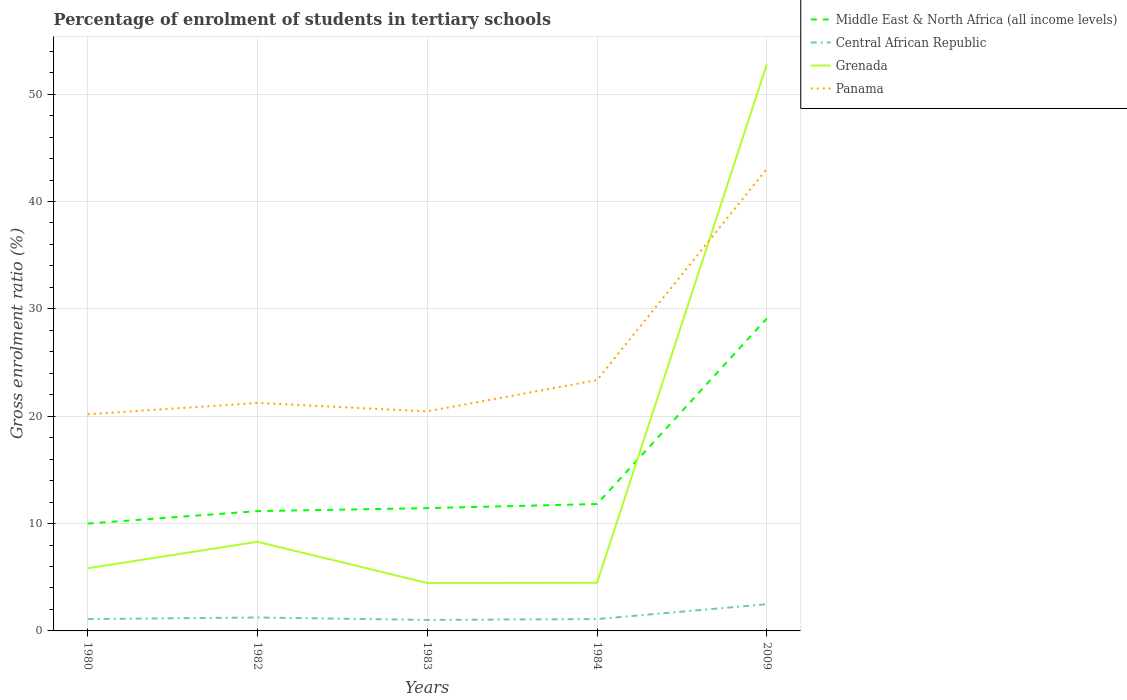Is the number of lines equal to the number of legend labels?
Provide a short and direct response. Yes. Across all years, what is the maximum percentage of students enrolled in tertiary schools in Middle East & North Africa (all income levels)?
Provide a succinct answer. 10. What is the total percentage of students enrolled in tertiary schools in Middle East & North Africa (all income levels) in the graph?
Provide a short and direct response. -0.38. What is the difference between the highest and the second highest percentage of students enrolled in tertiary schools in Grenada?
Make the answer very short. 48.31. Is the percentage of students enrolled in tertiary schools in Panama strictly greater than the percentage of students enrolled in tertiary schools in Central African Republic over the years?
Offer a terse response. No. How many lines are there?
Offer a very short reply. 4. How many years are there in the graph?
Provide a short and direct response. 5. Are the values on the major ticks of Y-axis written in scientific E-notation?
Ensure brevity in your answer.  No. Does the graph contain grids?
Your answer should be compact. Yes. Where does the legend appear in the graph?
Make the answer very short. Top right. How are the legend labels stacked?
Your answer should be compact. Vertical. What is the title of the graph?
Keep it short and to the point. Percentage of enrolment of students in tertiary schools. Does "Guinea" appear as one of the legend labels in the graph?
Ensure brevity in your answer.  No. What is the label or title of the X-axis?
Offer a very short reply. Years. What is the label or title of the Y-axis?
Provide a succinct answer. Gross enrolment ratio (%). What is the Gross enrolment ratio (%) in Middle East & North Africa (all income levels) in 1980?
Give a very brief answer. 10. What is the Gross enrolment ratio (%) in Central African Republic in 1980?
Provide a short and direct response. 1.1. What is the Gross enrolment ratio (%) in Grenada in 1980?
Make the answer very short. 5.83. What is the Gross enrolment ratio (%) of Panama in 1980?
Your answer should be very brief. 20.18. What is the Gross enrolment ratio (%) of Middle East & North Africa (all income levels) in 1982?
Provide a succinct answer. 11.16. What is the Gross enrolment ratio (%) in Central African Republic in 1982?
Give a very brief answer. 1.25. What is the Gross enrolment ratio (%) of Grenada in 1982?
Ensure brevity in your answer.  8.3. What is the Gross enrolment ratio (%) of Panama in 1982?
Provide a succinct answer. 21.24. What is the Gross enrolment ratio (%) in Middle East & North Africa (all income levels) in 1983?
Make the answer very short. 11.44. What is the Gross enrolment ratio (%) in Central African Republic in 1983?
Provide a succinct answer. 1.02. What is the Gross enrolment ratio (%) in Grenada in 1983?
Provide a succinct answer. 4.47. What is the Gross enrolment ratio (%) in Panama in 1983?
Provide a short and direct response. 20.45. What is the Gross enrolment ratio (%) of Middle East & North Africa (all income levels) in 1984?
Give a very brief answer. 11.82. What is the Gross enrolment ratio (%) of Central African Republic in 1984?
Keep it short and to the point. 1.1. What is the Gross enrolment ratio (%) of Grenada in 1984?
Provide a short and direct response. 4.48. What is the Gross enrolment ratio (%) of Panama in 1984?
Your answer should be compact. 23.36. What is the Gross enrolment ratio (%) in Middle East & North Africa (all income levels) in 2009?
Give a very brief answer. 29.1. What is the Gross enrolment ratio (%) in Central African Republic in 2009?
Your answer should be very brief. 2.49. What is the Gross enrolment ratio (%) of Grenada in 2009?
Give a very brief answer. 52.77. What is the Gross enrolment ratio (%) in Panama in 2009?
Make the answer very short. 43.03. Across all years, what is the maximum Gross enrolment ratio (%) of Middle East & North Africa (all income levels)?
Provide a succinct answer. 29.1. Across all years, what is the maximum Gross enrolment ratio (%) in Central African Republic?
Provide a short and direct response. 2.49. Across all years, what is the maximum Gross enrolment ratio (%) of Grenada?
Your response must be concise. 52.77. Across all years, what is the maximum Gross enrolment ratio (%) of Panama?
Your response must be concise. 43.03. Across all years, what is the minimum Gross enrolment ratio (%) of Middle East & North Africa (all income levels)?
Provide a succinct answer. 10. Across all years, what is the minimum Gross enrolment ratio (%) of Central African Republic?
Offer a terse response. 1.02. Across all years, what is the minimum Gross enrolment ratio (%) of Grenada?
Ensure brevity in your answer.  4.47. Across all years, what is the minimum Gross enrolment ratio (%) in Panama?
Give a very brief answer. 20.18. What is the total Gross enrolment ratio (%) in Middle East & North Africa (all income levels) in the graph?
Your response must be concise. 73.52. What is the total Gross enrolment ratio (%) in Central African Republic in the graph?
Ensure brevity in your answer.  6.97. What is the total Gross enrolment ratio (%) of Grenada in the graph?
Provide a short and direct response. 75.86. What is the total Gross enrolment ratio (%) of Panama in the graph?
Ensure brevity in your answer.  128.26. What is the difference between the Gross enrolment ratio (%) of Middle East & North Africa (all income levels) in 1980 and that in 1982?
Provide a short and direct response. -1.16. What is the difference between the Gross enrolment ratio (%) in Central African Republic in 1980 and that in 1982?
Offer a very short reply. -0.15. What is the difference between the Gross enrolment ratio (%) of Grenada in 1980 and that in 1982?
Make the answer very short. -2.47. What is the difference between the Gross enrolment ratio (%) of Panama in 1980 and that in 1982?
Your answer should be very brief. -1.05. What is the difference between the Gross enrolment ratio (%) in Middle East & North Africa (all income levels) in 1980 and that in 1983?
Offer a terse response. -1.44. What is the difference between the Gross enrolment ratio (%) of Central African Republic in 1980 and that in 1983?
Keep it short and to the point. 0.08. What is the difference between the Gross enrolment ratio (%) in Grenada in 1980 and that in 1983?
Offer a terse response. 1.37. What is the difference between the Gross enrolment ratio (%) of Panama in 1980 and that in 1983?
Give a very brief answer. -0.27. What is the difference between the Gross enrolment ratio (%) of Middle East & North Africa (all income levels) in 1980 and that in 1984?
Offer a terse response. -1.82. What is the difference between the Gross enrolment ratio (%) in Central African Republic in 1980 and that in 1984?
Your answer should be very brief. -0. What is the difference between the Gross enrolment ratio (%) of Grenada in 1980 and that in 1984?
Make the answer very short. 1.35. What is the difference between the Gross enrolment ratio (%) of Panama in 1980 and that in 1984?
Your answer should be very brief. -3.18. What is the difference between the Gross enrolment ratio (%) in Middle East & North Africa (all income levels) in 1980 and that in 2009?
Ensure brevity in your answer.  -19.1. What is the difference between the Gross enrolment ratio (%) of Central African Republic in 1980 and that in 2009?
Keep it short and to the point. -1.39. What is the difference between the Gross enrolment ratio (%) in Grenada in 1980 and that in 2009?
Offer a terse response. -46.94. What is the difference between the Gross enrolment ratio (%) in Panama in 1980 and that in 2009?
Provide a succinct answer. -22.85. What is the difference between the Gross enrolment ratio (%) in Middle East & North Africa (all income levels) in 1982 and that in 1983?
Provide a succinct answer. -0.28. What is the difference between the Gross enrolment ratio (%) in Central African Republic in 1982 and that in 1983?
Keep it short and to the point. 0.23. What is the difference between the Gross enrolment ratio (%) of Grenada in 1982 and that in 1983?
Ensure brevity in your answer.  3.84. What is the difference between the Gross enrolment ratio (%) of Panama in 1982 and that in 1983?
Your answer should be compact. 0.79. What is the difference between the Gross enrolment ratio (%) in Middle East & North Africa (all income levels) in 1982 and that in 1984?
Offer a very short reply. -0.66. What is the difference between the Gross enrolment ratio (%) in Central African Republic in 1982 and that in 1984?
Keep it short and to the point. 0.15. What is the difference between the Gross enrolment ratio (%) of Grenada in 1982 and that in 1984?
Offer a terse response. 3.82. What is the difference between the Gross enrolment ratio (%) in Panama in 1982 and that in 1984?
Your answer should be very brief. -2.12. What is the difference between the Gross enrolment ratio (%) in Middle East & North Africa (all income levels) in 1982 and that in 2009?
Offer a very short reply. -17.94. What is the difference between the Gross enrolment ratio (%) in Central African Republic in 1982 and that in 2009?
Keep it short and to the point. -1.24. What is the difference between the Gross enrolment ratio (%) of Grenada in 1982 and that in 2009?
Your answer should be compact. -44.47. What is the difference between the Gross enrolment ratio (%) of Panama in 1982 and that in 2009?
Provide a short and direct response. -21.79. What is the difference between the Gross enrolment ratio (%) of Middle East & North Africa (all income levels) in 1983 and that in 1984?
Offer a very short reply. -0.38. What is the difference between the Gross enrolment ratio (%) in Central African Republic in 1983 and that in 1984?
Your response must be concise. -0.08. What is the difference between the Gross enrolment ratio (%) in Grenada in 1983 and that in 1984?
Your answer should be compact. -0.02. What is the difference between the Gross enrolment ratio (%) of Panama in 1983 and that in 1984?
Make the answer very short. -2.91. What is the difference between the Gross enrolment ratio (%) of Middle East & North Africa (all income levels) in 1983 and that in 2009?
Offer a terse response. -17.67. What is the difference between the Gross enrolment ratio (%) of Central African Republic in 1983 and that in 2009?
Provide a short and direct response. -1.47. What is the difference between the Gross enrolment ratio (%) of Grenada in 1983 and that in 2009?
Give a very brief answer. -48.31. What is the difference between the Gross enrolment ratio (%) of Panama in 1983 and that in 2009?
Offer a terse response. -22.58. What is the difference between the Gross enrolment ratio (%) in Middle East & North Africa (all income levels) in 1984 and that in 2009?
Provide a short and direct response. -17.29. What is the difference between the Gross enrolment ratio (%) in Central African Republic in 1984 and that in 2009?
Provide a short and direct response. -1.39. What is the difference between the Gross enrolment ratio (%) of Grenada in 1984 and that in 2009?
Offer a terse response. -48.29. What is the difference between the Gross enrolment ratio (%) in Panama in 1984 and that in 2009?
Offer a very short reply. -19.67. What is the difference between the Gross enrolment ratio (%) in Middle East & North Africa (all income levels) in 1980 and the Gross enrolment ratio (%) in Central African Republic in 1982?
Keep it short and to the point. 8.75. What is the difference between the Gross enrolment ratio (%) in Middle East & North Africa (all income levels) in 1980 and the Gross enrolment ratio (%) in Grenada in 1982?
Provide a succinct answer. 1.7. What is the difference between the Gross enrolment ratio (%) of Middle East & North Africa (all income levels) in 1980 and the Gross enrolment ratio (%) of Panama in 1982?
Your answer should be compact. -11.24. What is the difference between the Gross enrolment ratio (%) in Central African Republic in 1980 and the Gross enrolment ratio (%) in Grenada in 1982?
Offer a terse response. -7.2. What is the difference between the Gross enrolment ratio (%) in Central African Republic in 1980 and the Gross enrolment ratio (%) in Panama in 1982?
Ensure brevity in your answer.  -20.14. What is the difference between the Gross enrolment ratio (%) of Grenada in 1980 and the Gross enrolment ratio (%) of Panama in 1982?
Keep it short and to the point. -15.4. What is the difference between the Gross enrolment ratio (%) of Middle East & North Africa (all income levels) in 1980 and the Gross enrolment ratio (%) of Central African Republic in 1983?
Offer a terse response. 8.98. What is the difference between the Gross enrolment ratio (%) in Middle East & North Africa (all income levels) in 1980 and the Gross enrolment ratio (%) in Grenada in 1983?
Your answer should be very brief. 5.53. What is the difference between the Gross enrolment ratio (%) of Middle East & North Africa (all income levels) in 1980 and the Gross enrolment ratio (%) of Panama in 1983?
Offer a very short reply. -10.45. What is the difference between the Gross enrolment ratio (%) in Central African Republic in 1980 and the Gross enrolment ratio (%) in Grenada in 1983?
Offer a very short reply. -3.36. What is the difference between the Gross enrolment ratio (%) of Central African Republic in 1980 and the Gross enrolment ratio (%) of Panama in 1983?
Provide a short and direct response. -19.35. What is the difference between the Gross enrolment ratio (%) of Grenada in 1980 and the Gross enrolment ratio (%) of Panama in 1983?
Offer a very short reply. -14.61. What is the difference between the Gross enrolment ratio (%) of Middle East & North Africa (all income levels) in 1980 and the Gross enrolment ratio (%) of Central African Republic in 1984?
Offer a very short reply. 8.9. What is the difference between the Gross enrolment ratio (%) in Middle East & North Africa (all income levels) in 1980 and the Gross enrolment ratio (%) in Grenada in 1984?
Offer a very short reply. 5.52. What is the difference between the Gross enrolment ratio (%) of Middle East & North Africa (all income levels) in 1980 and the Gross enrolment ratio (%) of Panama in 1984?
Your answer should be compact. -13.36. What is the difference between the Gross enrolment ratio (%) of Central African Republic in 1980 and the Gross enrolment ratio (%) of Grenada in 1984?
Provide a short and direct response. -3.38. What is the difference between the Gross enrolment ratio (%) in Central African Republic in 1980 and the Gross enrolment ratio (%) in Panama in 1984?
Provide a succinct answer. -22.26. What is the difference between the Gross enrolment ratio (%) in Grenada in 1980 and the Gross enrolment ratio (%) in Panama in 1984?
Keep it short and to the point. -17.53. What is the difference between the Gross enrolment ratio (%) in Middle East & North Africa (all income levels) in 1980 and the Gross enrolment ratio (%) in Central African Republic in 2009?
Make the answer very short. 7.51. What is the difference between the Gross enrolment ratio (%) in Middle East & North Africa (all income levels) in 1980 and the Gross enrolment ratio (%) in Grenada in 2009?
Offer a terse response. -42.77. What is the difference between the Gross enrolment ratio (%) of Middle East & North Africa (all income levels) in 1980 and the Gross enrolment ratio (%) of Panama in 2009?
Your answer should be compact. -33.03. What is the difference between the Gross enrolment ratio (%) of Central African Republic in 1980 and the Gross enrolment ratio (%) of Grenada in 2009?
Give a very brief answer. -51.67. What is the difference between the Gross enrolment ratio (%) in Central African Republic in 1980 and the Gross enrolment ratio (%) in Panama in 2009?
Your answer should be compact. -41.93. What is the difference between the Gross enrolment ratio (%) of Grenada in 1980 and the Gross enrolment ratio (%) of Panama in 2009?
Keep it short and to the point. -37.2. What is the difference between the Gross enrolment ratio (%) of Middle East & North Africa (all income levels) in 1982 and the Gross enrolment ratio (%) of Central African Republic in 1983?
Provide a short and direct response. 10.13. What is the difference between the Gross enrolment ratio (%) of Middle East & North Africa (all income levels) in 1982 and the Gross enrolment ratio (%) of Grenada in 1983?
Your answer should be very brief. 6.69. What is the difference between the Gross enrolment ratio (%) in Middle East & North Africa (all income levels) in 1982 and the Gross enrolment ratio (%) in Panama in 1983?
Offer a terse response. -9.29. What is the difference between the Gross enrolment ratio (%) of Central African Republic in 1982 and the Gross enrolment ratio (%) of Grenada in 1983?
Provide a succinct answer. -3.21. What is the difference between the Gross enrolment ratio (%) of Central African Republic in 1982 and the Gross enrolment ratio (%) of Panama in 1983?
Provide a short and direct response. -19.2. What is the difference between the Gross enrolment ratio (%) in Grenada in 1982 and the Gross enrolment ratio (%) in Panama in 1983?
Your response must be concise. -12.15. What is the difference between the Gross enrolment ratio (%) of Middle East & North Africa (all income levels) in 1982 and the Gross enrolment ratio (%) of Central African Republic in 1984?
Make the answer very short. 10.05. What is the difference between the Gross enrolment ratio (%) in Middle East & North Africa (all income levels) in 1982 and the Gross enrolment ratio (%) in Grenada in 1984?
Your answer should be very brief. 6.68. What is the difference between the Gross enrolment ratio (%) in Middle East & North Africa (all income levels) in 1982 and the Gross enrolment ratio (%) in Panama in 1984?
Make the answer very short. -12.2. What is the difference between the Gross enrolment ratio (%) in Central African Republic in 1982 and the Gross enrolment ratio (%) in Grenada in 1984?
Provide a short and direct response. -3.23. What is the difference between the Gross enrolment ratio (%) of Central African Republic in 1982 and the Gross enrolment ratio (%) of Panama in 1984?
Offer a terse response. -22.11. What is the difference between the Gross enrolment ratio (%) in Grenada in 1982 and the Gross enrolment ratio (%) in Panama in 1984?
Keep it short and to the point. -15.06. What is the difference between the Gross enrolment ratio (%) in Middle East & North Africa (all income levels) in 1982 and the Gross enrolment ratio (%) in Central African Republic in 2009?
Your answer should be compact. 8.67. What is the difference between the Gross enrolment ratio (%) of Middle East & North Africa (all income levels) in 1982 and the Gross enrolment ratio (%) of Grenada in 2009?
Your answer should be very brief. -41.61. What is the difference between the Gross enrolment ratio (%) in Middle East & North Africa (all income levels) in 1982 and the Gross enrolment ratio (%) in Panama in 2009?
Give a very brief answer. -31.87. What is the difference between the Gross enrolment ratio (%) in Central African Republic in 1982 and the Gross enrolment ratio (%) in Grenada in 2009?
Your answer should be very brief. -51.52. What is the difference between the Gross enrolment ratio (%) in Central African Republic in 1982 and the Gross enrolment ratio (%) in Panama in 2009?
Give a very brief answer. -41.78. What is the difference between the Gross enrolment ratio (%) of Grenada in 1982 and the Gross enrolment ratio (%) of Panama in 2009?
Your answer should be compact. -34.73. What is the difference between the Gross enrolment ratio (%) of Middle East & North Africa (all income levels) in 1983 and the Gross enrolment ratio (%) of Central African Republic in 1984?
Your response must be concise. 10.33. What is the difference between the Gross enrolment ratio (%) of Middle East & North Africa (all income levels) in 1983 and the Gross enrolment ratio (%) of Grenada in 1984?
Your response must be concise. 6.95. What is the difference between the Gross enrolment ratio (%) in Middle East & North Africa (all income levels) in 1983 and the Gross enrolment ratio (%) in Panama in 1984?
Make the answer very short. -11.92. What is the difference between the Gross enrolment ratio (%) of Central African Republic in 1983 and the Gross enrolment ratio (%) of Grenada in 1984?
Make the answer very short. -3.46. What is the difference between the Gross enrolment ratio (%) in Central African Republic in 1983 and the Gross enrolment ratio (%) in Panama in 1984?
Your answer should be very brief. -22.34. What is the difference between the Gross enrolment ratio (%) of Grenada in 1983 and the Gross enrolment ratio (%) of Panama in 1984?
Make the answer very short. -18.9. What is the difference between the Gross enrolment ratio (%) in Middle East & North Africa (all income levels) in 1983 and the Gross enrolment ratio (%) in Central African Republic in 2009?
Provide a succinct answer. 8.95. What is the difference between the Gross enrolment ratio (%) in Middle East & North Africa (all income levels) in 1983 and the Gross enrolment ratio (%) in Grenada in 2009?
Give a very brief answer. -41.34. What is the difference between the Gross enrolment ratio (%) in Middle East & North Africa (all income levels) in 1983 and the Gross enrolment ratio (%) in Panama in 2009?
Give a very brief answer. -31.59. What is the difference between the Gross enrolment ratio (%) of Central African Republic in 1983 and the Gross enrolment ratio (%) of Grenada in 2009?
Provide a succinct answer. -51.75. What is the difference between the Gross enrolment ratio (%) in Central African Republic in 1983 and the Gross enrolment ratio (%) in Panama in 2009?
Ensure brevity in your answer.  -42.01. What is the difference between the Gross enrolment ratio (%) in Grenada in 1983 and the Gross enrolment ratio (%) in Panama in 2009?
Provide a short and direct response. -38.56. What is the difference between the Gross enrolment ratio (%) of Middle East & North Africa (all income levels) in 1984 and the Gross enrolment ratio (%) of Central African Republic in 2009?
Ensure brevity in your answer.  9.33. What is the difference between the Gross enrolment ratio (%) of Middle East & North Africa (all income levels) in 1984 and the Gross enrolment ratio (%) of Grenada in 2009?
Provide a succinct answer. -40.96. What is the difference between the Gross enrolment ratio (%) of Middle East & North Africa (all income levels) in 1984 and the Gross enrolment ratio (%) of Panama in 2009?
Offer a very short reply. -31.21. What is the difference between the Gross enrolment ratio (%) in Central African Republic in 1984 and the Gross enrolment ratio (%) in Grenada in 2009?
Make the answer very short. -51.67. What is the difference between the Gross enrolment ratio (%) of Central African Republic in 1984 and the Gross enrolment ratio (%) of Panama in 2009?
Your answer should be compact. -41.93. What is the difference between the Gross enrolment ratio (%) in Grenada in 1984 and the Gross enrolment ratio (%) in Panama in 2009?
Your answer should be compact. -38.55. What is the average Gross enrolment ratio (%) of Middle East & North Africa (all income levels) per year?
Your answer should be compact. 14.7. What is the average Gross enrolment ratio (%) in Central African Republic per year?
Your answer should be very brief. 1.39. What is the average Gross enrolment ratio (%) in Grenada per year?
Provide a succinct answer. 15.17. What is the average Gross enrolment ratio (%) of Panama per year?
Your response must be concise. 25.65. In the year 1980, what is the difference between the Gross enrolment ratio (%) of Middle East & North Africa (all income levels) and Gross enrolment ratio (%) of Central African Republic?
Offer a terse response. 8.9. In the year 1980, what is the difference between the Gross enrolment ratio (%) of Middle East & North Africa (all income levels) and Gross enrolment ratio (%) of Grenada?
Your answer should be very brief. 4.17. In the year 1980, what is the difference between the Gross enrolment ratio (%) of Middle East & North Africa (all income levels) and Gross enrolment ratio (%) of Panama?
Keep it short and to the point. -10.18. In the year 1980, what is the difference between the Gross enrolment ratio (%) of Central African Republic and Gross enrolment ratio (%) of Grenada?
Ensure brevity in your answer.  -4.73. In the year 1980, what is the difference between the Gross enrolment ratio (%) of Central African Republic and Gross enrolment ratio (%) of Panama?
Provide a short and direct response. -19.08. In the year 1980, what is the difference between the Gross enrolment ratio (%) of Grenada and Gross enrolment ratio (%) of Panama?
Give a very brief answer. -14.35. In the year 1982, what is the difference between the Gross enrolment ratio (%) in Middle East & North Africa (all income levels) and Gross enrolment ratio (%) in Central African Republic?
Keep it short and to the point. 9.91. In the year 1982, what is the difference between the Gross enrolment ratio (%) in Middle East & North Africa (all income levels) and Gross enrolment ratio (%) in Grenada?
Offer a terse response. 2.86. In the year 1982, what is the difference between the Gross enrolment ratio (%) in Middle East & North Africa (all income levels) and Gross enrolment ratio (%) in Panama?
Make the answer very short. -10.08. In the year 1982, what is the difference between the Gross enrolment ratio (%) of Central African Republic and Gross enrolment ratio (%) of Grenada?
Make the answer very short. -7.05. In the year 1982, what is the difference between the Gross enrolment ratio (%) of Central African Republic and Gross enrolment ratio (%) of Panama?
Your answer should be very brief. -19.99. In the year 1982, what is the difference between the Gross enrolment ratio (%) of Grenada and Gross enrolment ratio (%) of Panama?
Make the answer very short. -12.93. In the year 1983, what is the difference between the Gross enrolment ratio (%) of Middle East & North Africa (all income levels) and Gross enrolment ratio (%) of Central African Republic?
Offer a terse response. 10.41. In the year 1983, what is the difference between the Gross enrolment ratio (%) of Middle East & North Africa (all income levels) and Gross enrolment ratio (%) of Grenada?
Your answer should be compact. 6.97. In the year 1983, what is the difference between the Gross enrolment ratio (%) of Middle East & North Africa (all income levels) and Gross enrolment ratio (%) of Panama?
Your answer should be very brief. -9.01. In the year 1983, what is the difference between the Gross enrolment ratio (%) in Central African Republic and Gross enrolment ratio (%) in Grenada?
Offer a terse response. -3.44. In the year 1983, what is the difference between the Gross enrolment ratio (%) of Central African Republic and Gross enrolment ratio (%) of Panama?
Give a very brief answer. -19.42. In the year 1983, what is the difference between the Gross enrolment ratio (%) in Grenada and Gross enrolment ratio (%) in Panama?
Offer a terse response. -15.98. In the year 1984, what is the difference between the Gross enrolment ratio (%) in Middle East & North Africa (all income levels) and Gross enrolment ratio (%) in Central African Republic?
Offer a very short reply. 10.71. In the year 1984, what is the difference between the Gross enrolment ratio (%) in Middle East & North Africa (all income levels) and Gross enrolment ratio (%) in Grenada?
Give a very brief answer. 7.33. In the year 1984, what is the difference between the Gross enrolment ratio (%) of Middle East & North Africa (all income levels) and Gross enrolment ratio (%) of Panama?
Your answer should be very brief. -11.54. In the year 1984, what is the difference between the Gross enrolment ratio (%) of Central African Republic and Gross enrolment ratio (%) of Grenada?
Your response must be concise. -3.38. In the year 1984, what is the difference between the Gross enrolment ratio (%) in Central African Republic and Gross enrolment ratio (%) in Panama?
Make the answer very short. -22.26. In the year 1984, what is the difference between the Gross enrolment ratio (%) in Grenada and Gross enrolment ratio (%) in Panama?
Give a very brief answer. -18.88. In the year 2009, what is the difference between the Gross enrolment ratio (%) of Middle East & North Africa (all income levels) and Gross enrolment ratio (%) of Central African Republic?
Provide a succinct answer. 26.61. In the year 2009, what is the difference between the Gross enrolment ratio (%) of Middle East & North Africa (all income levels) and Gross enrolment ratio (%) of Grenada?
Provide a short and direct response. -23.67. In the year 2009, what is the difference between the Gross enrolment ratio (%) in Middle East & North Africa (all income levels) and Gross enrolment ratio (%) in Panama?
Ensure brevity in your answer.  -13.93. In the year 2009, what is the difference between the Gross enrolment ratio (%) of Central African Republic and Gross enrolment ratio (%) of Grenada?
Provide a short and direct response. -50.28. In the year 2009, what is the difference between the Gross enrolment ratio (%) in Central African Republic and Gross enrolment ratio (%) in Panama?
Your answer should be compact. -40.54. In the year 2009, what is the difference between the Gross enrolment ratio (%) in Grenada and Gross enrolment ratio (%) in Panama?
Offer a terse response. 9.74. What is the ratio of the Gross enrolment ratio (%) of Middle East & North Africa (all income levels) in 1980 to that in 1982?
Make the answer very short. 0.9. What is the ratio of the Gross enrolment ratio (%) of Central African Republic in 1980 to that in 1982?
Your response must be concise. 0.88. What is the ratio of the Gross enrolment ratio (%) of Grenada in 1980 to that in 1982?
Offer a terse response. 0.7. What is the ratio of the Gross enrolment ratio (%) of Panama in 1980 to that in 1982?
Your answer should be compact. 0.95. What is the ratio of the Gross enrolment ratio (%) in Middle East & North Africa (all income levels) in 1980 to that in 1983?
Provide a short and direct response. 0.87. What is the ratio of the Gross enrolment ratio (%) in Central African Republic in 1980 to that in 1983?
Give a very brief answer. 1.08. What is the ratio of the Gross enrolment ratio (%) of Grenada in 1980 to that in 1983?
Keep it short and to the point. 1.31. What is the ratio of the Gross enrolment ratio (%) in Panama in 1980 to that in 1983?
Make the answer very short. 0.99. What is the ratio of the Gross enrolment ratio (%) of Middle East & North Africa (all income levels) in 1980 to that in 1984?
Provide a succinct answer. 0.85. What is the ratio of the Gross enrolment ratio (%) of Grenada in 1980 to that in 1984?
Ensure brevity in your answer.  1.3. What is the ratio of the Gross enrolment ratio (%) of Panama in 1980 to that in 1984?
Your answer should be very brief. 0.86. What is the ratio of the Gross enrolment ratio (%) of Middle East & North Africa (all income levels) in 1980 to that in 2009?
Provide a short and direct response. 0.34. What is the ratio of the Gross enrolment ratio (%) in Central African Republic in 1980 to that in 2009?
Make the answer very short. 0.44. What is the ratio of the Gross enrolment ratio (%) in Grenada in 1980 to that in 2009?
Offer a very short reply. 0.11. What is the ratio of the Gross enrolment ratio (%) in Panama in 1980 to that in 2009?
Offer a terse response. 0.47. What is the ratio of the Gross enrolment ratio (%) of Middle East & North Africa (all income levels) in 1982 to that in 1983?
Your answer should be very brief. 0.98. What is the ratio of the Gross enrolment ratio (%) in Central African Republic in 1982 to that in 1983?
Provide a succinct answer. 1.22. What is the ratio of the Gross enrolment ratio (%) in Grenada in 1982 to that in 1983?
Provide a short and direct response. 1.86. What is the ratio of the Gross enrolment ratio (%) in Panama in 1982 to that in 1983?
Your answer should be compact. 1.04. What is the ratio of the Gross enrolment ratio (%) of Middle East & North Africa (all income levels) in 1982 to that in 1984?
Ensure brevity in your answer.  0.94. What is the ratio of the Gross enrolment ratio (%) in Central African Republic in 1982 to that in 1984?
Ensure brevity in your answer.  1.13. What is the ratio of the Gross enrolment ratio (%) in Grenada in 1982 to that in 1984?
Your answer should be very brief. 1.85. What is the ratio of the Gross enrolment ratio (%) of Panama in 1982 to that in 1984?
Offer a terse response. 0.91. What is the ratio of the Gross enrolment ratio (%) in Middle East & North Africa (all income levels) in 1982 to that in 2009?
Provide a succinct answer. 0.38. What is the ratio of the Gross enrolment ratio (%) in Central African Republic in 1982 to that in 2009?
Provide a succinct answer. 0.5. What is the ratio of the Gross enrolment ratio (%) of Grenada in 1982 to that in 2009?
Your answer should be compact. 0.16. What is the ratio of the Gross enrolment ratio (%) of Panama in 1982 to that in 2009?
Provide a short and direct response. 0.49. What is the ratio of the Gross enrolment ratio (%) of Middle East & North Africa (all income levels) in 1983 to that in 1984?
Make the answer very short. 0.97. What is the ratio of the Gross enrolment ratio (%) in Central African Republic in 1983 to that in 1984?
Your answer should be very brief. 0.93. What is the ratio of the Gross enrolment ratio (%) in Panama in 1983 to that in 1984?
Offer a very short reply. 0.88. What is the ratio of the Gross enrolment ratio (%) of Middle East & North Africa (all income levels) in 1983 to that in 2009?
Your answer should be compact. 0.39. What is the ratio of the Gross enrolment ratio (%) in Central African Republic in 1983 to that in 2009?
Provide a succinct answer. 0.41. What is the ratio of the Gross enrolment ratio (%) of Grenada in 1983 to that in 2009?
Make the answer very short. 0.08. What is the ratio of the Gross enrolment ratio (%) in Panama in 1983 to that in 2009?
Offer a terse response. 0.48. What is the ratio of the Gross enrolment ratio (%) in Middle East & North Africa (all income levels) in 1984 to that in 2009?
Offer a terse response. 0.41. What is the ratio of the Gross enrolment ratio (%) in Central African Republic in 1984 to that in 2009?
Ensure brevity in your answer.  0.44. What is the ratio of the Gross enrolment ratio (%) in Grenada in 1984 to that in 2009?
Offer a terse response. 0.09. What is the ratio of the Gross enrolment ratio (%) in Panama in 1984 to that in 2009?
Offer a very short reply. 0.54. What is the difference between the highest and the second highest Gross enrolment ratio (%) of Middle East & North Africa (all income levels)?
Make the answer very short. 17.29. What is the difference between the highest and the second highest Gross enrolment ratio (%) of Central African Republic?
Your answer should be compact. 1.24. What is the difference between the highest and the second highest Gross enrolment ratio (%) in Grenada?
Keep it short and to the point. 44.47. What is the difference between the highest and the second highest Gross enrolment ratio (%) in Panama?
Your answer should be compact. 19.67. What is the difference between the highest and the lowest Gross enrolment ratio (%) of Middle East & North Africa (all income levels)?
Offer a very short reply. 19.1. What is the difference between the highest and the lowest Gross enrolment ratio (%) of Central African Republic?
Keep it short and to the point. 1.47. What is the difference between the highest and the lowest Gross enrolment ratio (%) in Grenada?
Provide a short and direct response. 48.31. What is the difference between the highest and the lowest Gross enrolment ratio (%) in Panama?
Make the answer very short. 22.85. 